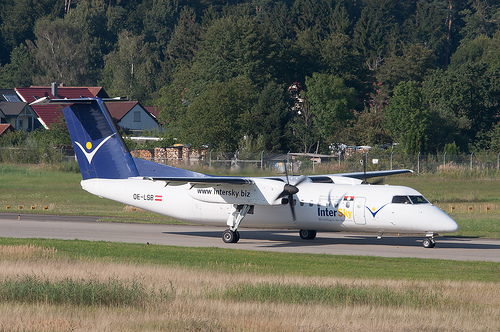Please provide a short description for this region: [0.07, 0.35, 0.3, 0.51]. The area at coordinates [0.07, 0.35, 0.3, 0.51] likely represents 'The tailwing on an airplane,' an essential aerodynamic feature for stability and control. 